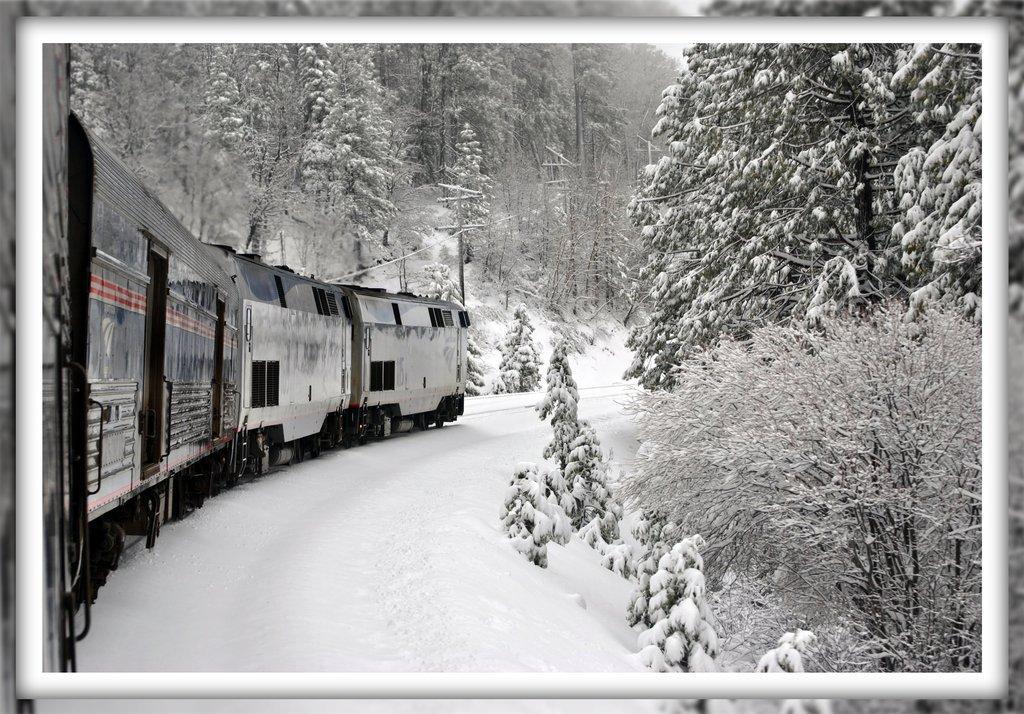Could you give a brief overview of what you see in this image? In the image we can see there is a train standing on the railway track and the ground is covered with snow. There are lot of trees which are covered with snow. 